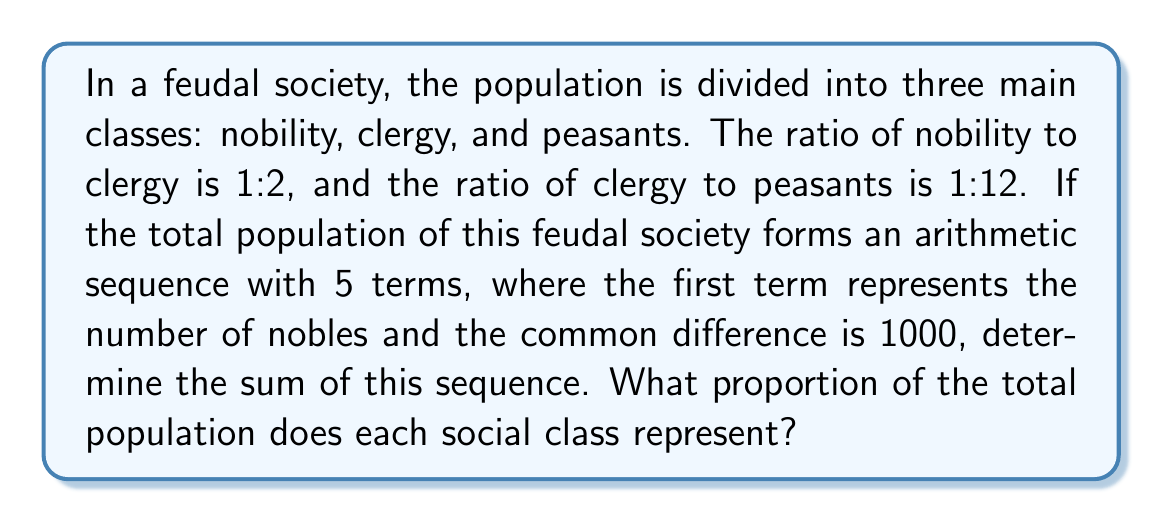Can you solve this math problem? Let's approach this step-by-step:

1) First, let's establish the ratios:
   Nobility : Clergy : Peasants = 1 : 2 : 24

2) Now, we know that these form an arithmetic sequence with 5 terms, where:
   $a_1$ = number of nobles
   $d$ = 1000 (common difference)

3) The arithmetic sequence will be:
   $a_1, a_1 + 1000, a_1 + 2000, a_1 + 3000, a_1 + 4000$

4) We know that $a_1$ represents nobility (1 part), $a_1 + 1000$ represents clergy (2 parts), and the sum of the last three terms represents peasants (24 parts).

5) Let's set up an equation:
   $a_1 + (a_1 + 1000) + (a_1 + 2000) + (a_1 + 3000) + (a_1 + 4000) = 27a_1$

6) Simplify:
   $5a_1 + 10000 = 27a_1$
   $10000 = 22a_1$
   $a_1 = \frac{10000}{22} = \frac{5000}{11} \approx 454.55$

7) Now we can calculate each term:
   Nobility: $\frac{5000}{11}$
   Clergy: $\frac{5000}{11} + 1000 = \frac{16000}{11} \approx 1454.55$
   Peasants: $\frac{5000}{11} + 2000 + \frac{5000}{11} + 3000 + \frac{5000}{11} + 4000 = \frac{65000}{11} \approx 5909.09$

8) The sum of the sequence is:
   $S_5 = \frac{5}{2}(2a_1 + 4d) = \frac{5}{2}(2\cdot\frac{5000}{11} + 4\cdot1000) = \frac{5}{2}(\frac{10000}{11} + 4000) = \frac{135000}{11} \approx 12272.73$

9) To calculate proportions:
   Nobility: $\frac{5000}{135000} = \frac{1}{27} \approx 3.70\%$
   Clergy: $\frac{16000}{135000} = \frac{32}{270} \approx 11.85\%$
   Peasants: $\frac{65000}{135000} = \frac{13}{27} \approx 84.44\%$
Answer: The sum of the sequence is $\frac{135000}{11}$. The proportions of each social class are:
Nobility: $\frac{1}{27} \approx 3.70\%$
Clergy: $\frac{32}{270} \approx 11.85\%$
Peasants: $\frac{13}{27} \approx 84.44\%$ 